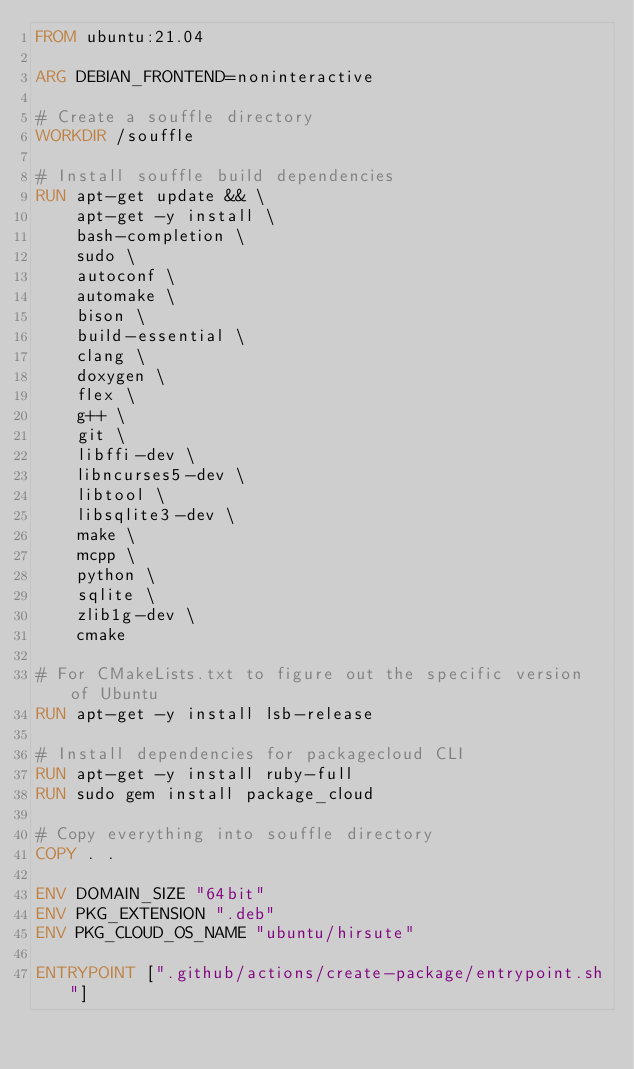Convert code to text. <code><loc_0><loc_0><loc_500><loc_500><_Dockerfile_>FROM ubuntu:21.04

ARG DEBIAN_FRONTEND=noninteractive

# Create a souffle directory
WORKDIR /souffle

# Install souffle build dependencies
RUN apt-get update && \
	apt-get -y install \
	bash-completion \
	sudo \
	autoconf \
	automake \
	bison \
	build-essential \
	clang \
	doxygen \
	flex \
	g++ \
	git \
	libffi-dev \
	libncurses5-dev \
	libtool \
	libsqlite3-dev \
	make \
	mcpp \
	python \
	sqlite \
	zlib1g-dev \
	cmake

# For CMakeLists.txt to figure out the specific version of Ubuntu
RUN apt-get -y install lsb-release

# Install dependencies for packagecloud CLI
RUN apt-get -y install ruby-full
RUN sudo gem install package_cloud

# Copy everything into souffle directory
COPY . .

ENV DOMAIN_SIZE "64bit"
ENV PKG_EXTENSION ".deb"
ENV PKG_CLOUD_OS_NAME "ubuntu/hirsute"

ENTRYPOINT [".github/actions/create-package/entrypoint.sh"]</code> 